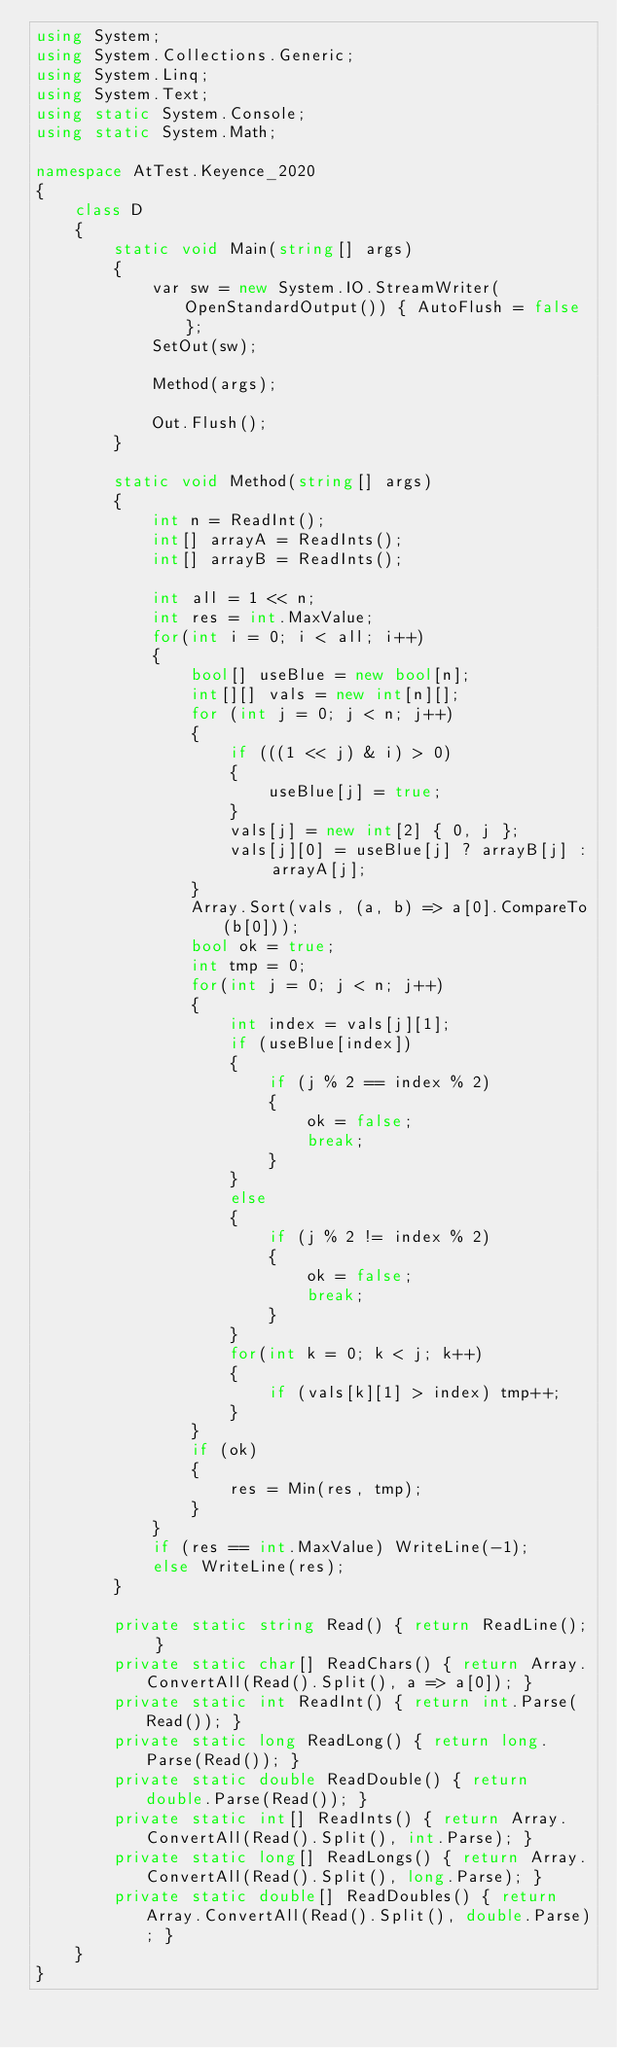Convert code to text. <code><loc_0><loc_0><loc_500><loc_500><_C#_>using System;
using System.Collections.Generic;
using System.Linq;
using System.Text;
using static System.Console;
using static System.Math;

namespace AtTest.Keyence_2020
{
    class D
    {
        static void Main(string[] args)
        {
            var sw = new System.IO.StreamWriter(OpenStandardOutput()) { AutoFlush = false };
            SetOut(sw);

            Method(args);

            Out.Flush();
        }

        static void Method(string[] args)
        {
            int n = ReadInt();
            int[] arrayA = ReadInts();
            int[] arrayB = ReadInts();

            int all = 1 << n;
            int res = int.MaxValue;
            for(int i = 0; i < all; i++)
            {
                bool[] useBlue = new bool[n];
                int[][] vals = new int[n][];
                for (int j = 0; j < n; j++)
                {
                    if (((1 << j) & i) > 0)
                    {
                        useBlue[j] = true;
                    }
                    vals[j] = new int[2] { 0, j };
                    vals[j][0] = useBlue[j] ? arrayB[j] : arrayA[j];
                }
                Array.Sort(vals, (a, b) => a[0].CompareTo(b[0]));
                bool ok = true;
                int tmp = 0;
                for(int j = 0; j < n; j++)
                {
                    int index = vals[j][1];
                    if (useBlue[index])
                    {
                        if (j % 2 == index % 2)
                        {
                            ok = false;
                            break;
                        }
                    }
                    else
                    {
                        if (j % 2 != index % 2)
                        {
                            ok = false;
                            break;
                        }
                    }
                    for(int k = 0; k < j; k++)
                    {
                        if (vals[k][1] > index) tmp++;
                    }
                }
                if (ok)
                {
                    res = Min(res, tmp);
                }
            }
            if (res == int.MaxValue) WriteLine(-1);
            else WriteLine(res);
        }

        private static string Read() { return ReadLine(); }
        private static char[] ReadChars() { return Array.ConvertAll(Read().Split(), a => a[0]); }
        private static int ReadInt() { return int.Parse(Read()); }
        private static long ReadLong() { return long.Parse(Read()); }
        private static double ReadDouble() { return double.Parse(Read()); }
        private static int[] ReadInts() { return Array.ConvertAll(Read().Split(), int.Parse); }
        private static long[] ReadLongs() { return Array.ConvertAll(Read().Split(), long.Parse); }
        private static double[] ReadDoubles() { return Array.ConvertAll(Read().Split(), double.Parse); }
    }
}
</code> 